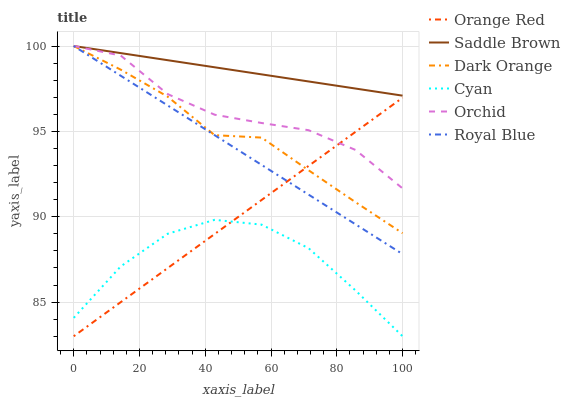Does Cyan have the minimum area under the curve?
Answer yes or no. Yes. Does Saddle Brown have the maximum area under the curve?
Answer yes or no. Yes. Does Royal Blue have the minimum area under the curve?
Answer yes or no. No. Does Royal Blue have the maximum area under the curve?
Answer yes or no. No. Is Royal Blue the smoothest?
Answer yes or no. Yes. Is Cyan the roughest?
Answer yes or no. Yes. Is Saddle Brown the smoothest?
Answer yes or no. No. Is Saddle Brown the roughest?
Answer yes or no. No. Does Royal Blue have the lowest value?
Answer yes or no. No. Does Cyan have the highest value?
Answer yes or no. No. Is Cyan less than Orchid?
Answer yes or no. Yes. Is Royal Blue greater than Cyan?
Answer yes or no. Yes. Does Cyan intersect Orchid?
Answer yes or no. No. 